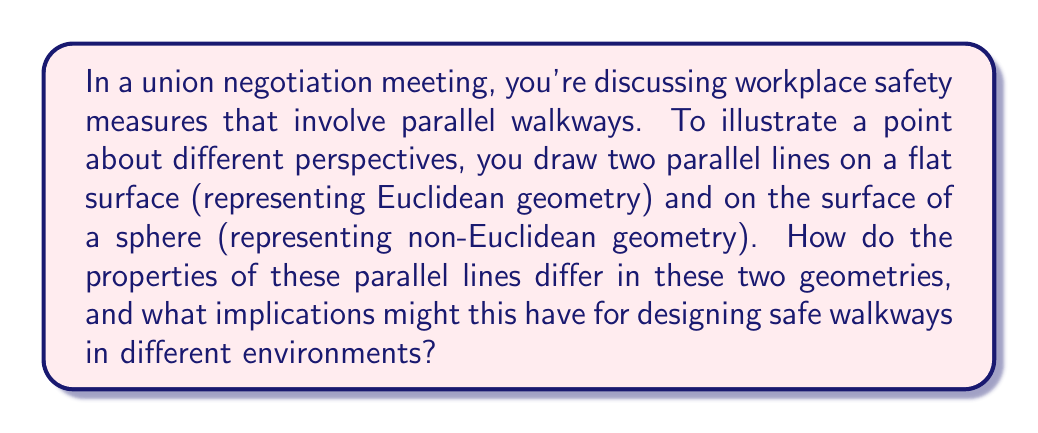Give your solution to this math problem. Let's break this down step-by-step:

1. Euclidean Geometry (flat surface):
   - In Euclidean geometry, parallel lines are always equidistant from each other.
   - They never intersect, no matter how far they are extended.
   - The sum of angles in a triangle formed by these lines is always 180°.

   [asy]
   import geometry;
   
   size(200);
   draw((0,0)--(100,0));
   draw((0,20)--(100,20));
   label("Euclidean parallel lines", (50,-10));
   [/asy]

2. Non-Euclidean Geometry (sphere surface):
   - On a sphere, "parallel" lines (great circles) are not equidistant.
   - They intersect at two antipodal points.
   - The sum of angles in a triangle formed by these lines is always > 180°.

   [asy]
   import geometry;
   
   size(200);
   draw(circle((0,0),50));
   draw(arc((0,0),50,0,180));
   draw(arc((0,0),50,45,225));
   label("Spherical 'parallel' lines", (0,-60));
   [/asy]

3. Implications for walkway design:
   - Euclidean (flat): Walkways can be designed to maintain constant separation.
   - Non-Euclidean (curved): Walkways will naturally converge or diverge.

4. Safety considerations:
   - Euclidean: Consistent spacing aids in predictable traffic flow and emergency planning.
   - Non-Euclidean: Variable spacing may require additional safety measures at convergence points.

5. Mathematical representation:
   - Euclidean parallel lines: $y = mx + b_1$ and $y = mx + b_2$ where $b_1 \neq b_2$
   - Spherical "parallel" lines: Great circles intersecting at antipodal points $(x, y, z)$ and $(-x, -y, -z)$ on a unit sphere $x^2 + y^2 + z^2 = 1$

This difference in parallel line behavior highlights the importance of considering the geometry of the environment when designing safety measures.
Answer: In Euclidean geometry, parallel lines remain equidistant and never intersect. In non-Euclidean (spherical) geometry, "parallel" lines are not equidistant and intersect at antipodal points. 